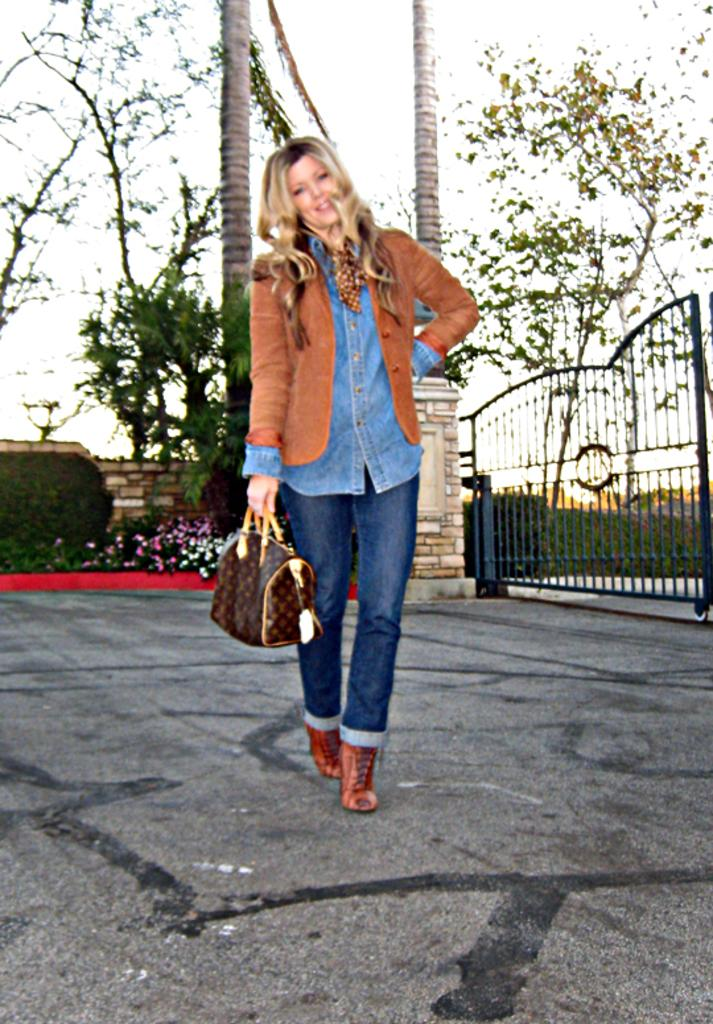What is the main feature of the image? There is a road in the image. What is the lady on the road doing? The lady is standing on the road, holding a bag. Can you describe any structures in the image? There is a gate visible in the image. What type of natural elements can be seen in the image? Trees and plants with flowers are present in the image. What is visible in the background of the image? The sky is visible in the image. What type of throne is the woman sitting on in the image? There is no woman sitting on a throne in the image; the lady is standing on the road, holding a bag. What company is responsible for the gate in the image? There is no information about a company being responsible for the gate in the image. 